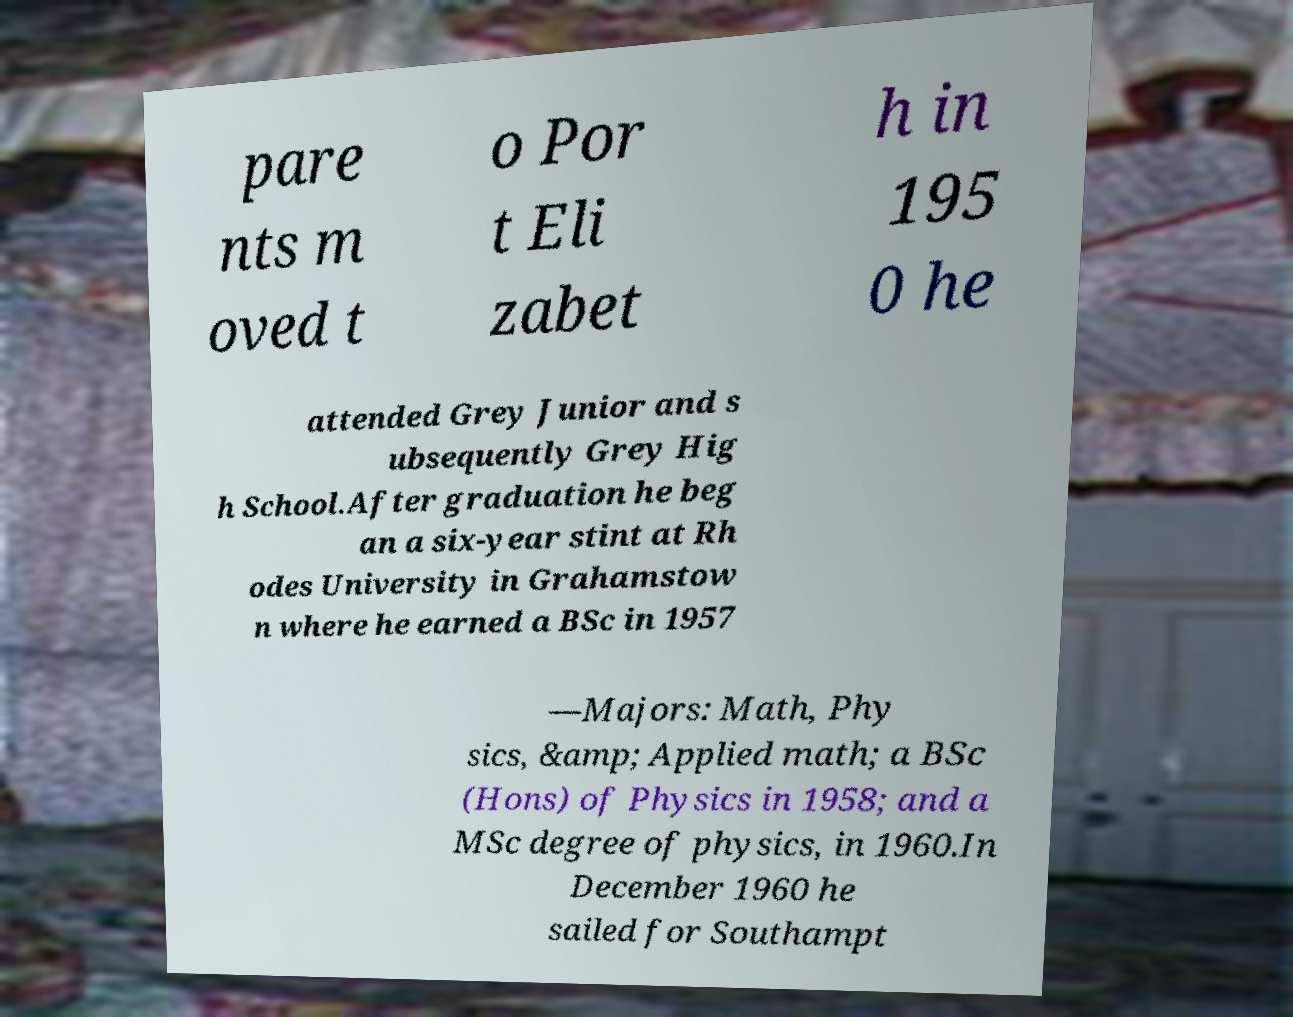There's text embedded in this image that I need extracted. Can you transcribe it verbatim? pare nts m oved t o Por t Eli zabet h in 195 0 he attended Grey Junior and s ubsequently Grey Hig h School.After graduation he beg an a six-year stint at Rh odes University in Grahamstow n where he earned a BSc in 1957 —Majors: Math, Phy sics, &amp; Applied math; a BSc (Hons) of Physics in 1958; and a MSc degree of physics, in 1960.In December 1960 he sailed for Southampt 